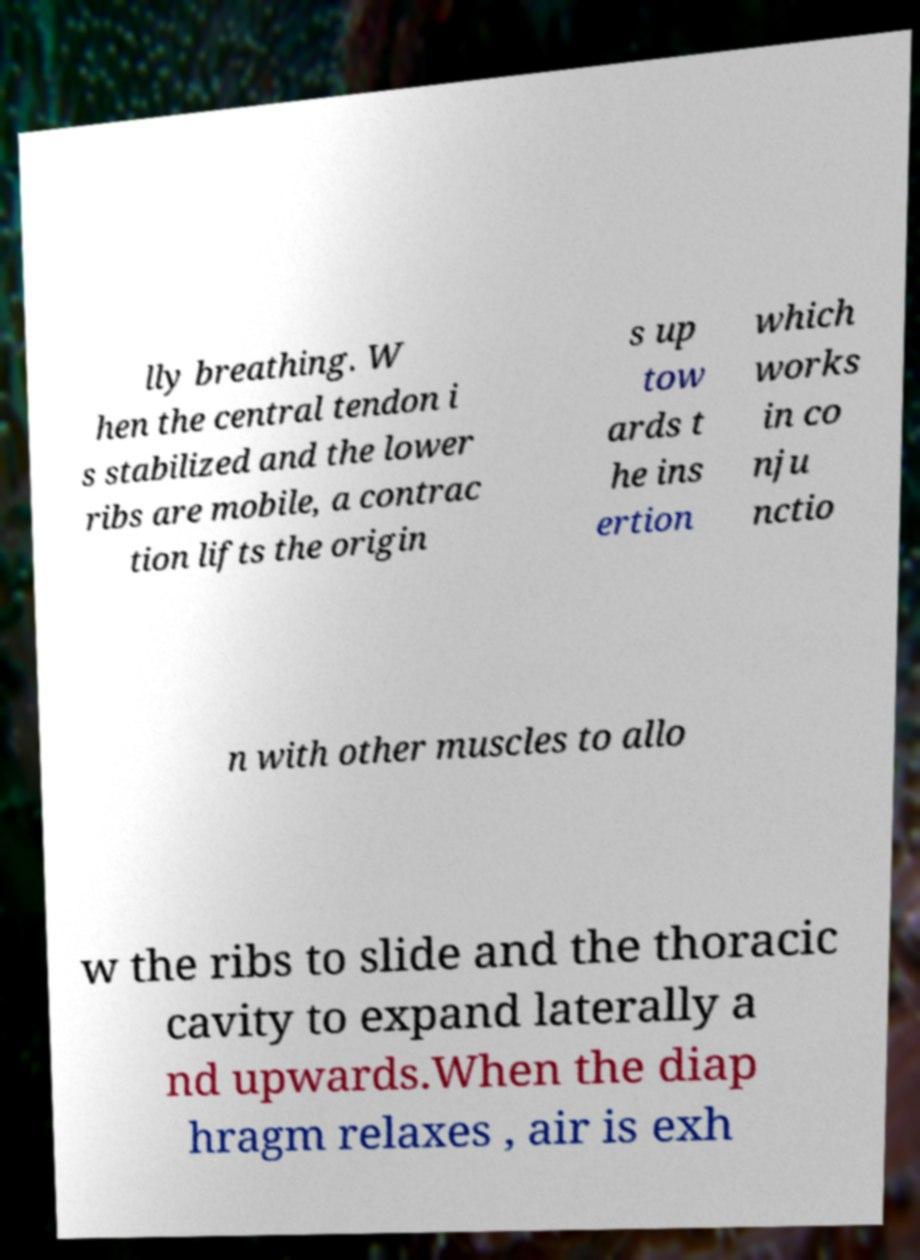Can you accurately transcribe the text from the provided image for me? lly breathing. W hen the central tendon i s stabilized and the lower ribs are mobile, a contrac tion lifts the origin s up tow ards t he ins ertion which works in co nju nctio n with other muscles to allo w the ribs to slide and the thoracic cavity to expand laterally a nd upwards.When the diap hragm relaxes , air is exh 